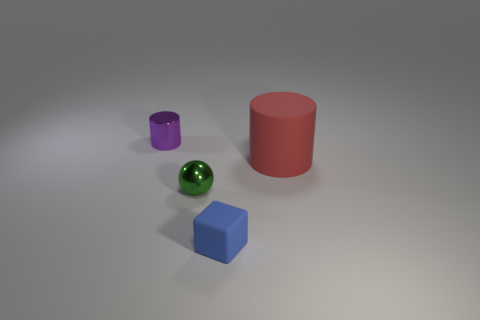Add 2 blue blocks. How many objects exist? 6 Subtract all cubes. How many objects are left? 3 Add 2 gray metallic objects. How many gray metallic objects exist? 2 Subtract 0 blue cylinders. How many objects are left? 4 Subtract all blue metal things. Subtract all small metallic cylinders. How many objects are left? 3 Add 2 red objects. How many red objects are left? 3 